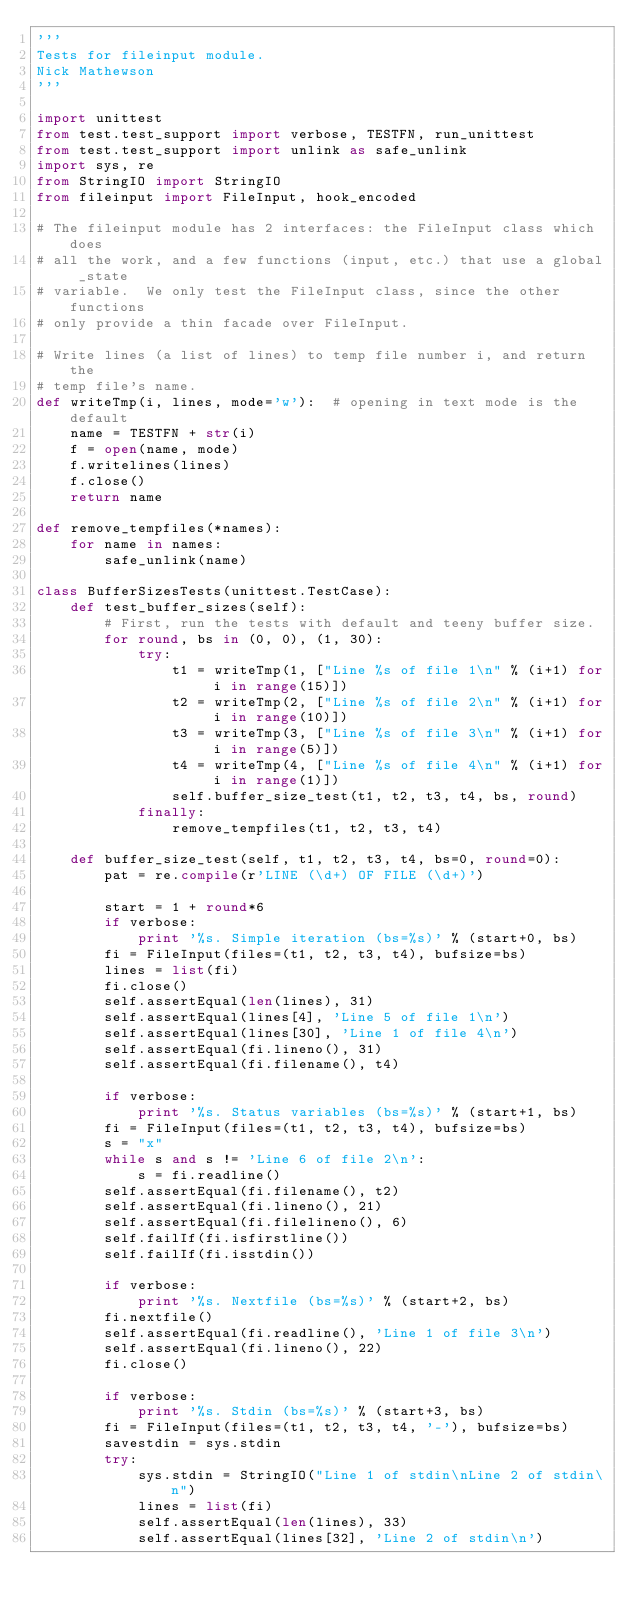<code> <loc_0><loc_0><loc_500><loc_500><_Python_>'''
Tests for fileinput module.
Nick Mathewson
'''

import unittest
from test.test_support import verbose, TESTFN, run_unittest
from test.test_support import unlink as safe_unlink
import sys, re
from StringIO import StringIO
from fileinput import FileInput, hook_encoded

# The fileinput module has 2 interfaces: the FileInput class which does
# all the work, and a few functions (input, etc.) that use a global _state
# variable.  We only test the FileInput class, since the other functions
# only provide a thin facade over FileInput.

# Write lines (a list of lines) to temp file number i, and return the
# temp file's name.
def writeTmp(i, lines, mode='w'):  # opening in text mode is the default
    name = TESTFN + str(i)
    f = open(name, mode)
    f.writelines(lines)
    f.close()
    return name

def remove_tempfiles(*names):
    for name in names:
        safe_unlink(name)

class BufferSizesTests(unittest.TestCase):
    def test_buffer_sizes(self):
        # First, run the tests with default and teeny buffer size.
        for round, bs in (0, 0), (1, 30):
            try:
                t1 = writeTmp(1, ["Line %s of file 1\n" % (i+1) for i in range(15)])
                t2 = writeTmp(2, ["Line %s of file 2\n" % (i+1) for i in range(10)])
                t3 = writeTmp(3, ["Line %s of file 3\n" % (i+1) for i in range(5)])
                t4 = writeTmp(4, ["Line %s of file 4\n" % (i+1) for i in range(1)])
                self.buffer_size_test(t1, t2, t3, t4, bs, round)
            finally:
                remove_tempfiles(t1, t2, t3, t4)

    def buffer_size_test(self, t1, t2, t3, t4, bs=0, round=0):
        pat = re.compile(r'LINE (\d+) OF FILE (\d+)')

        start = 1 + round*6
        if verbose:
            print '%s. Simple iteration (bs=%s)' % (start+0, bs)
        fi = FileInput(files=(t1, t2, t3, t4), bufsize=bs)
        lines = list(fi)
        fi.close()
        self.assertEqual(len(lines), 31)
        self.assertEqual(lines[4], 'Line 5 of file 1\n')
        self.assertEqual(lines[30], 'Line 1 of file 4\n')
        self.assertEqual(fi.lineno(), 31)
        self.assertEqual(fi.filename(), t4)

        if verbose:
            print '%s. Status variables (bs=%s)' % (start+1, bs)
        fi = FileInput(files=(t1, t2, t3, t4), bufsize=bs)
        s = "x"
        while s and s != 'Line 6 of file 2\n':
            s = fi.readline()
        self.assertEqual(fi.filename(), t2)
        self.assertEqual(fi.lineno(), 21)
        self.assertEqual(fi.filelineno(), 6)
        self.failIf(fi.isfirstline())
        self.failIf(fi.isstdin())

        if verbose:
            print '%s. Nextfile (bs=%s)' % (start+2, bs)
        fi.nextfile()
        self.assertEqual(fi.readline(), 'Line 1 of file 3\n')
        self.assertEqual(fi.lineno(), 22)
        fi.close()

        if verbose:
            print '%s. Stdin (bs=%s)' % (start+3, bs)
        fi = FileInput(files=(t1, t2, t3, t4, '-'), bufsize=bs)
        savestdin = sys.stdin
        try:
            sys.stdin = StringIO("Line 1 of stdin\nLine 2 of stdin\n")
            lines = list(fi)
            self.assertEqual(len(lines), 33)
            self.assertEqual(lines[32], 'Line 2 of stdin\n')</code> 